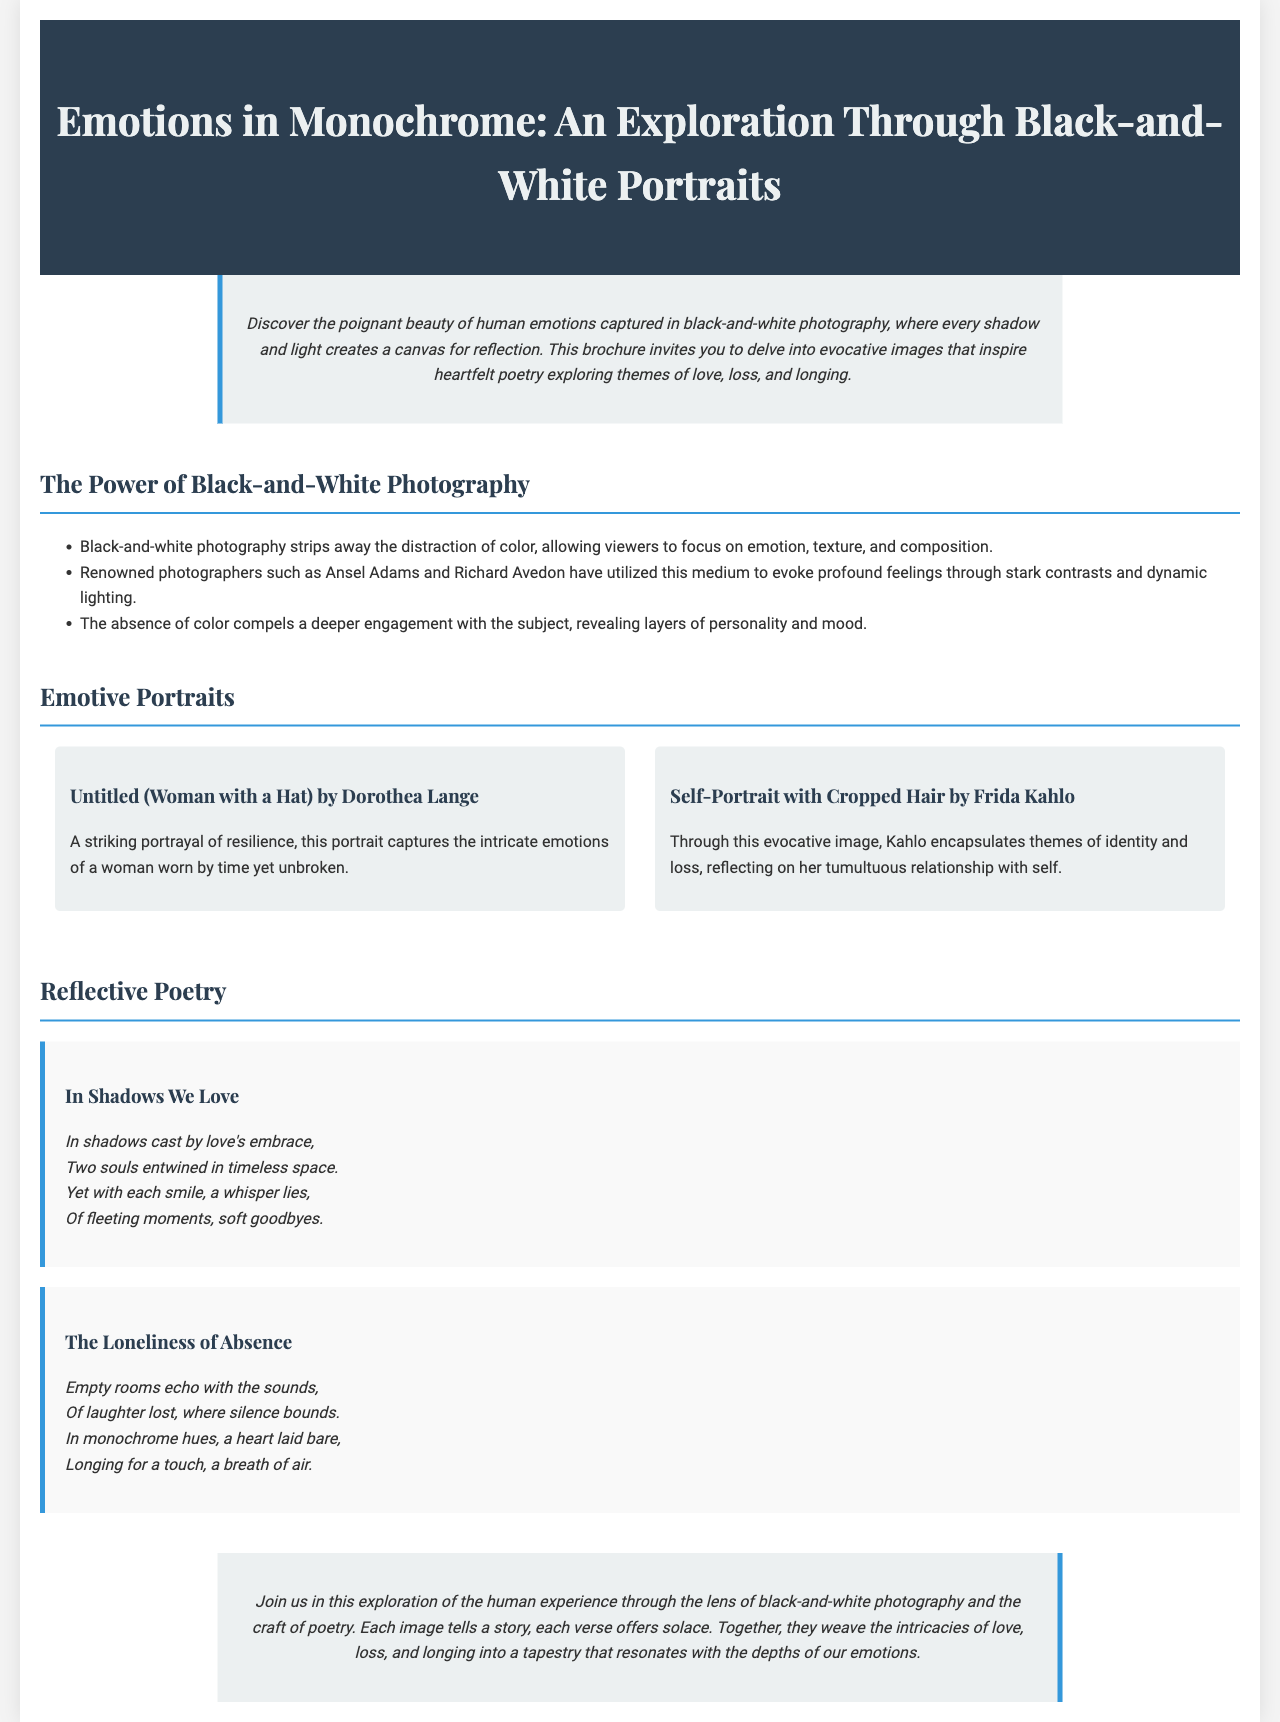what is the title of the brochure? The title is prominently displayed at the top of the document, introducing the theme of the exploration.
Answer: Emotions in Monochrome: An Exploration Through Black-and-White Portraits who is the photographer of "Self-Portrait with Cropped Hair"? The document mentions this photograph and attributes it to a well-known artist reflecting her identity.
Answer: Frida Kahlo how many poems are included in the brochure? The section on reflective poetry contains two poems, as listed in the document.
Answer: 2 what theme do the photographs explore? The introduction summarizes the emotional themes present in the black-and-white photography featured.
Answer: human emotions name one renowned photographer mentioned in the document. The document cites this photographer as a key figure in the field of black-and-white photography.
Answer: Ansel Adams what is the first poem titled? The titles of the poems are clearly indicated in the poetry section of the brochure.
Answer: In Shadows We Love what do the portraits aim to evoke? The introduction encapsulates the overall goal of the photographs presented in the brochure.
Answer: poignant beauty what color scheme is used in the photography? The document specifically highlights the absence of color in the photographs, which captures the essence of the theme.
Answer: black-and-white 